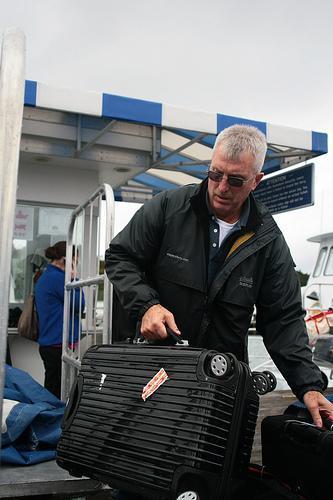How many suitcases does the man have?
Give a very brief answer. 2. How many suitcases are there?
Give a very brief answer. 2. 